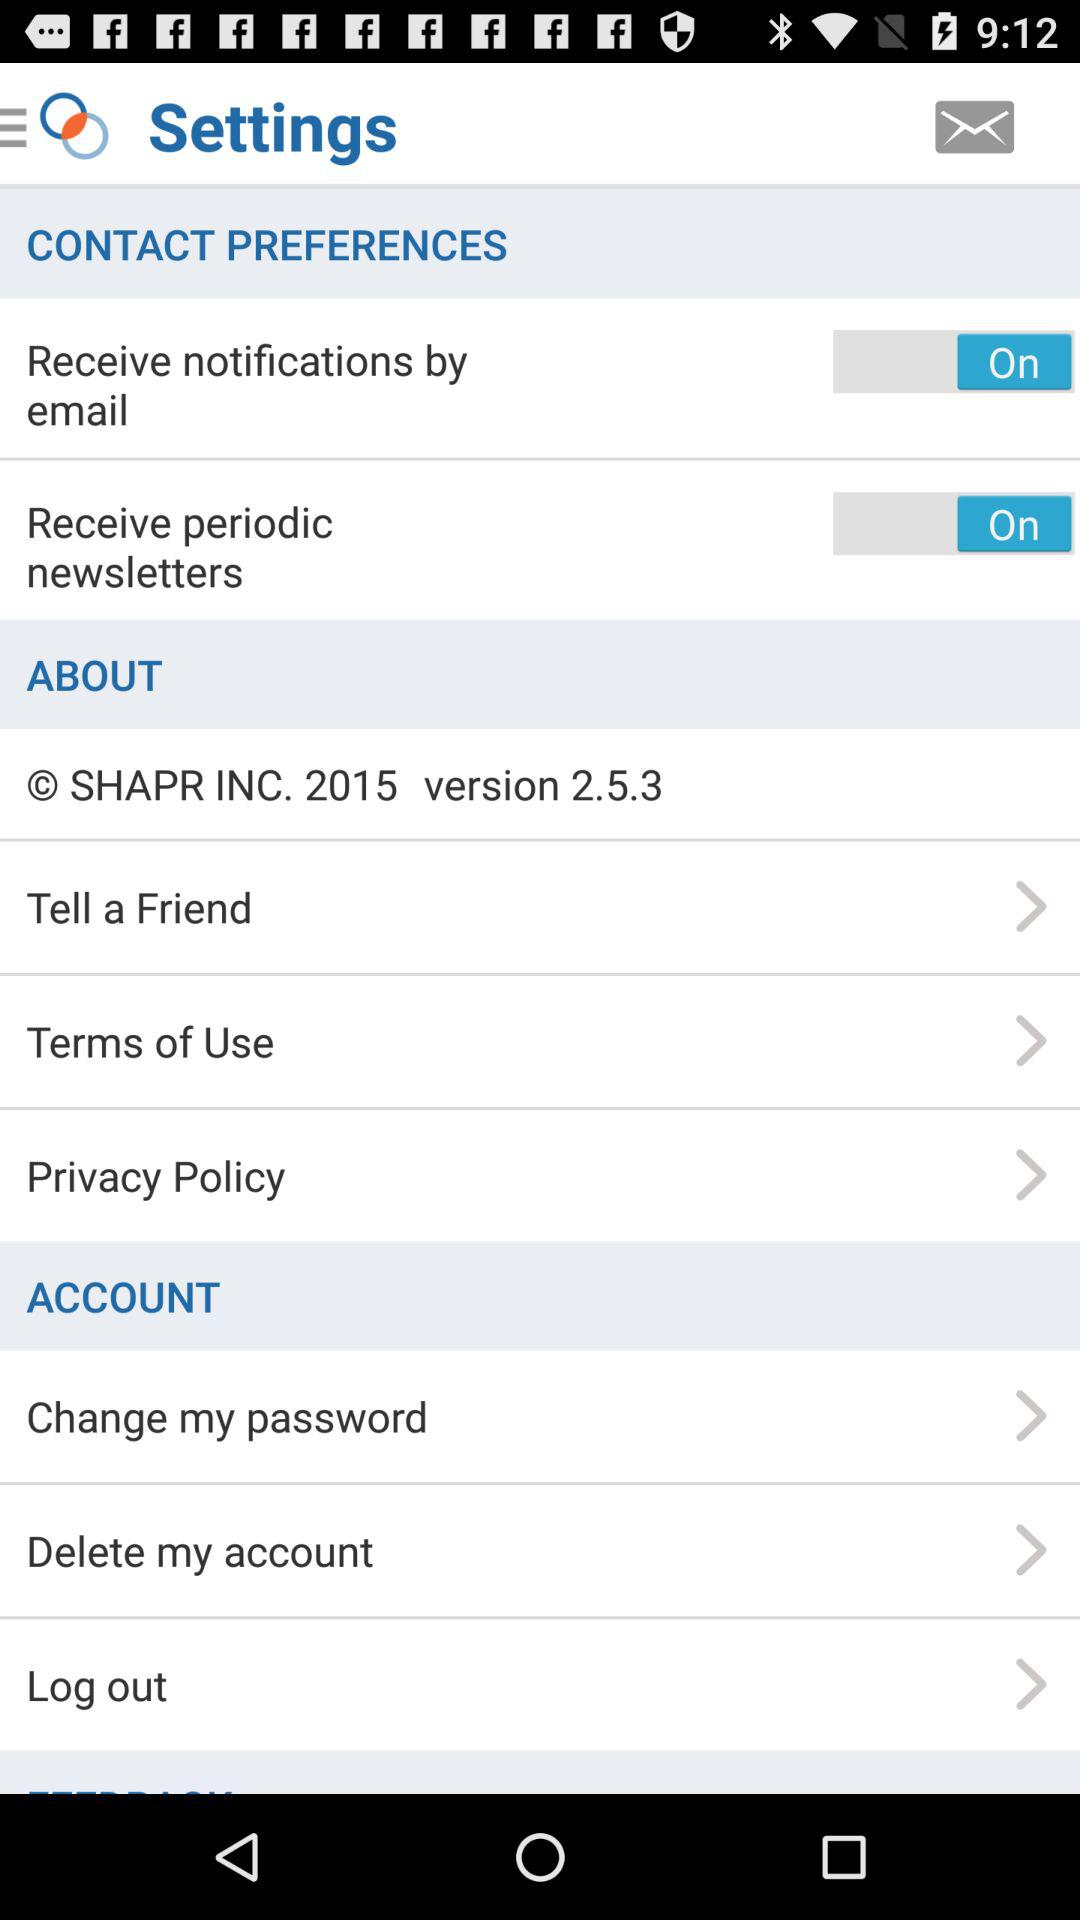What is the status of "Receive periodic newsletters"? The status is "On". 